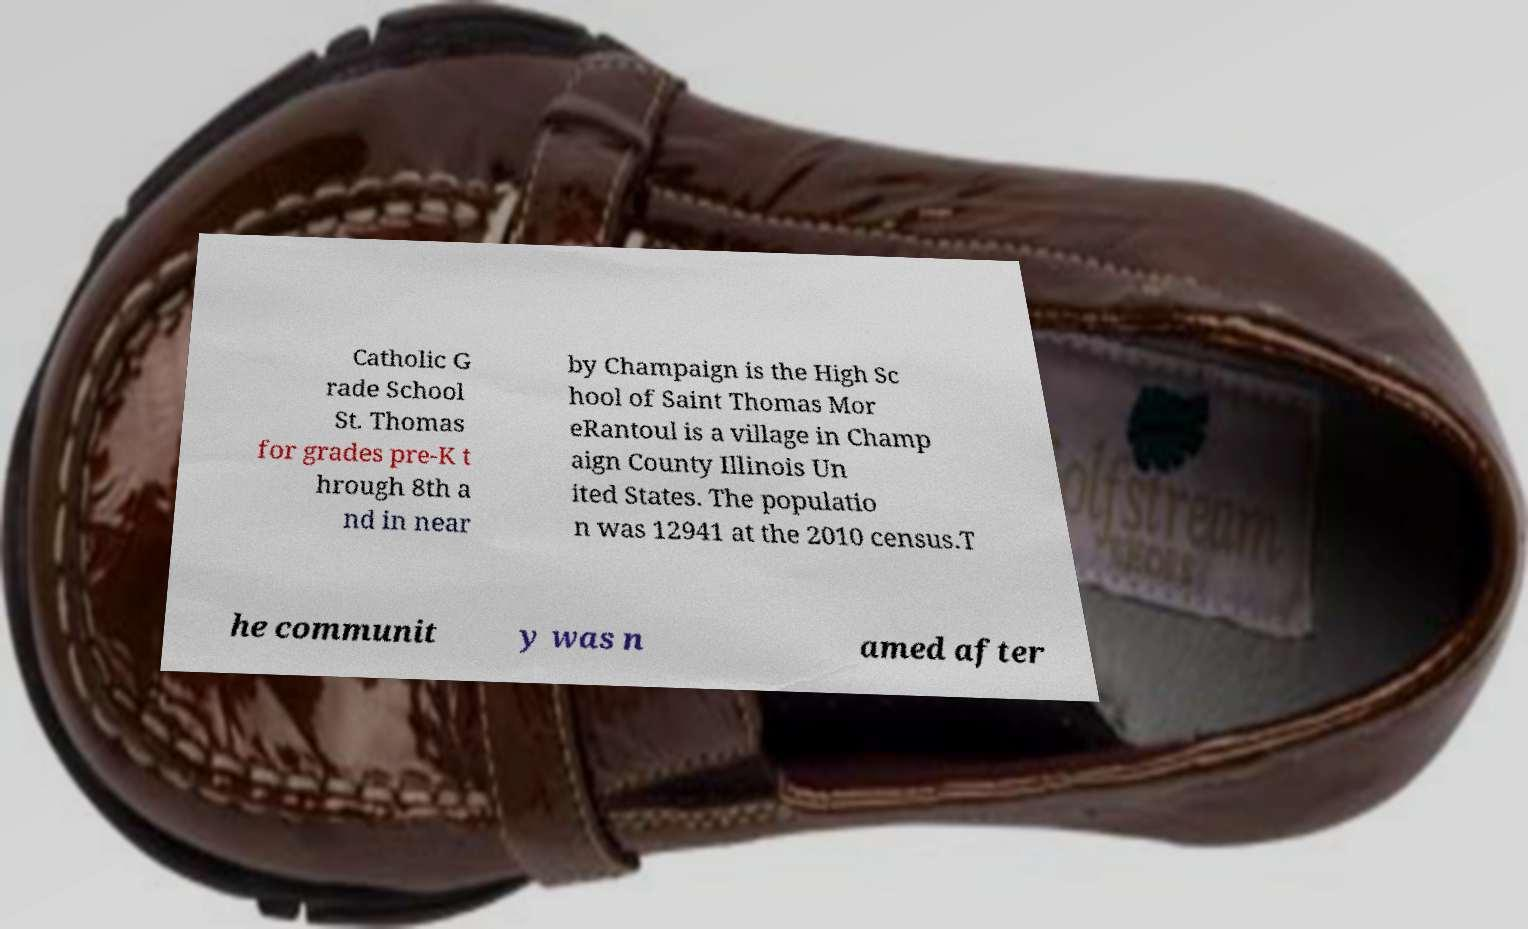Please read and relay the text visible in this image. What does it say? Catholic G rade School St. Thomas for grades pre-K t hrough 8th a nd in near by Champaign is the High Sc hool of Saint Thomas Mor eRantoul is a village in Champ aign County Illinois Un ited States. The populatio n was 12941 at the 2010 census.T he communit y was n amed after 